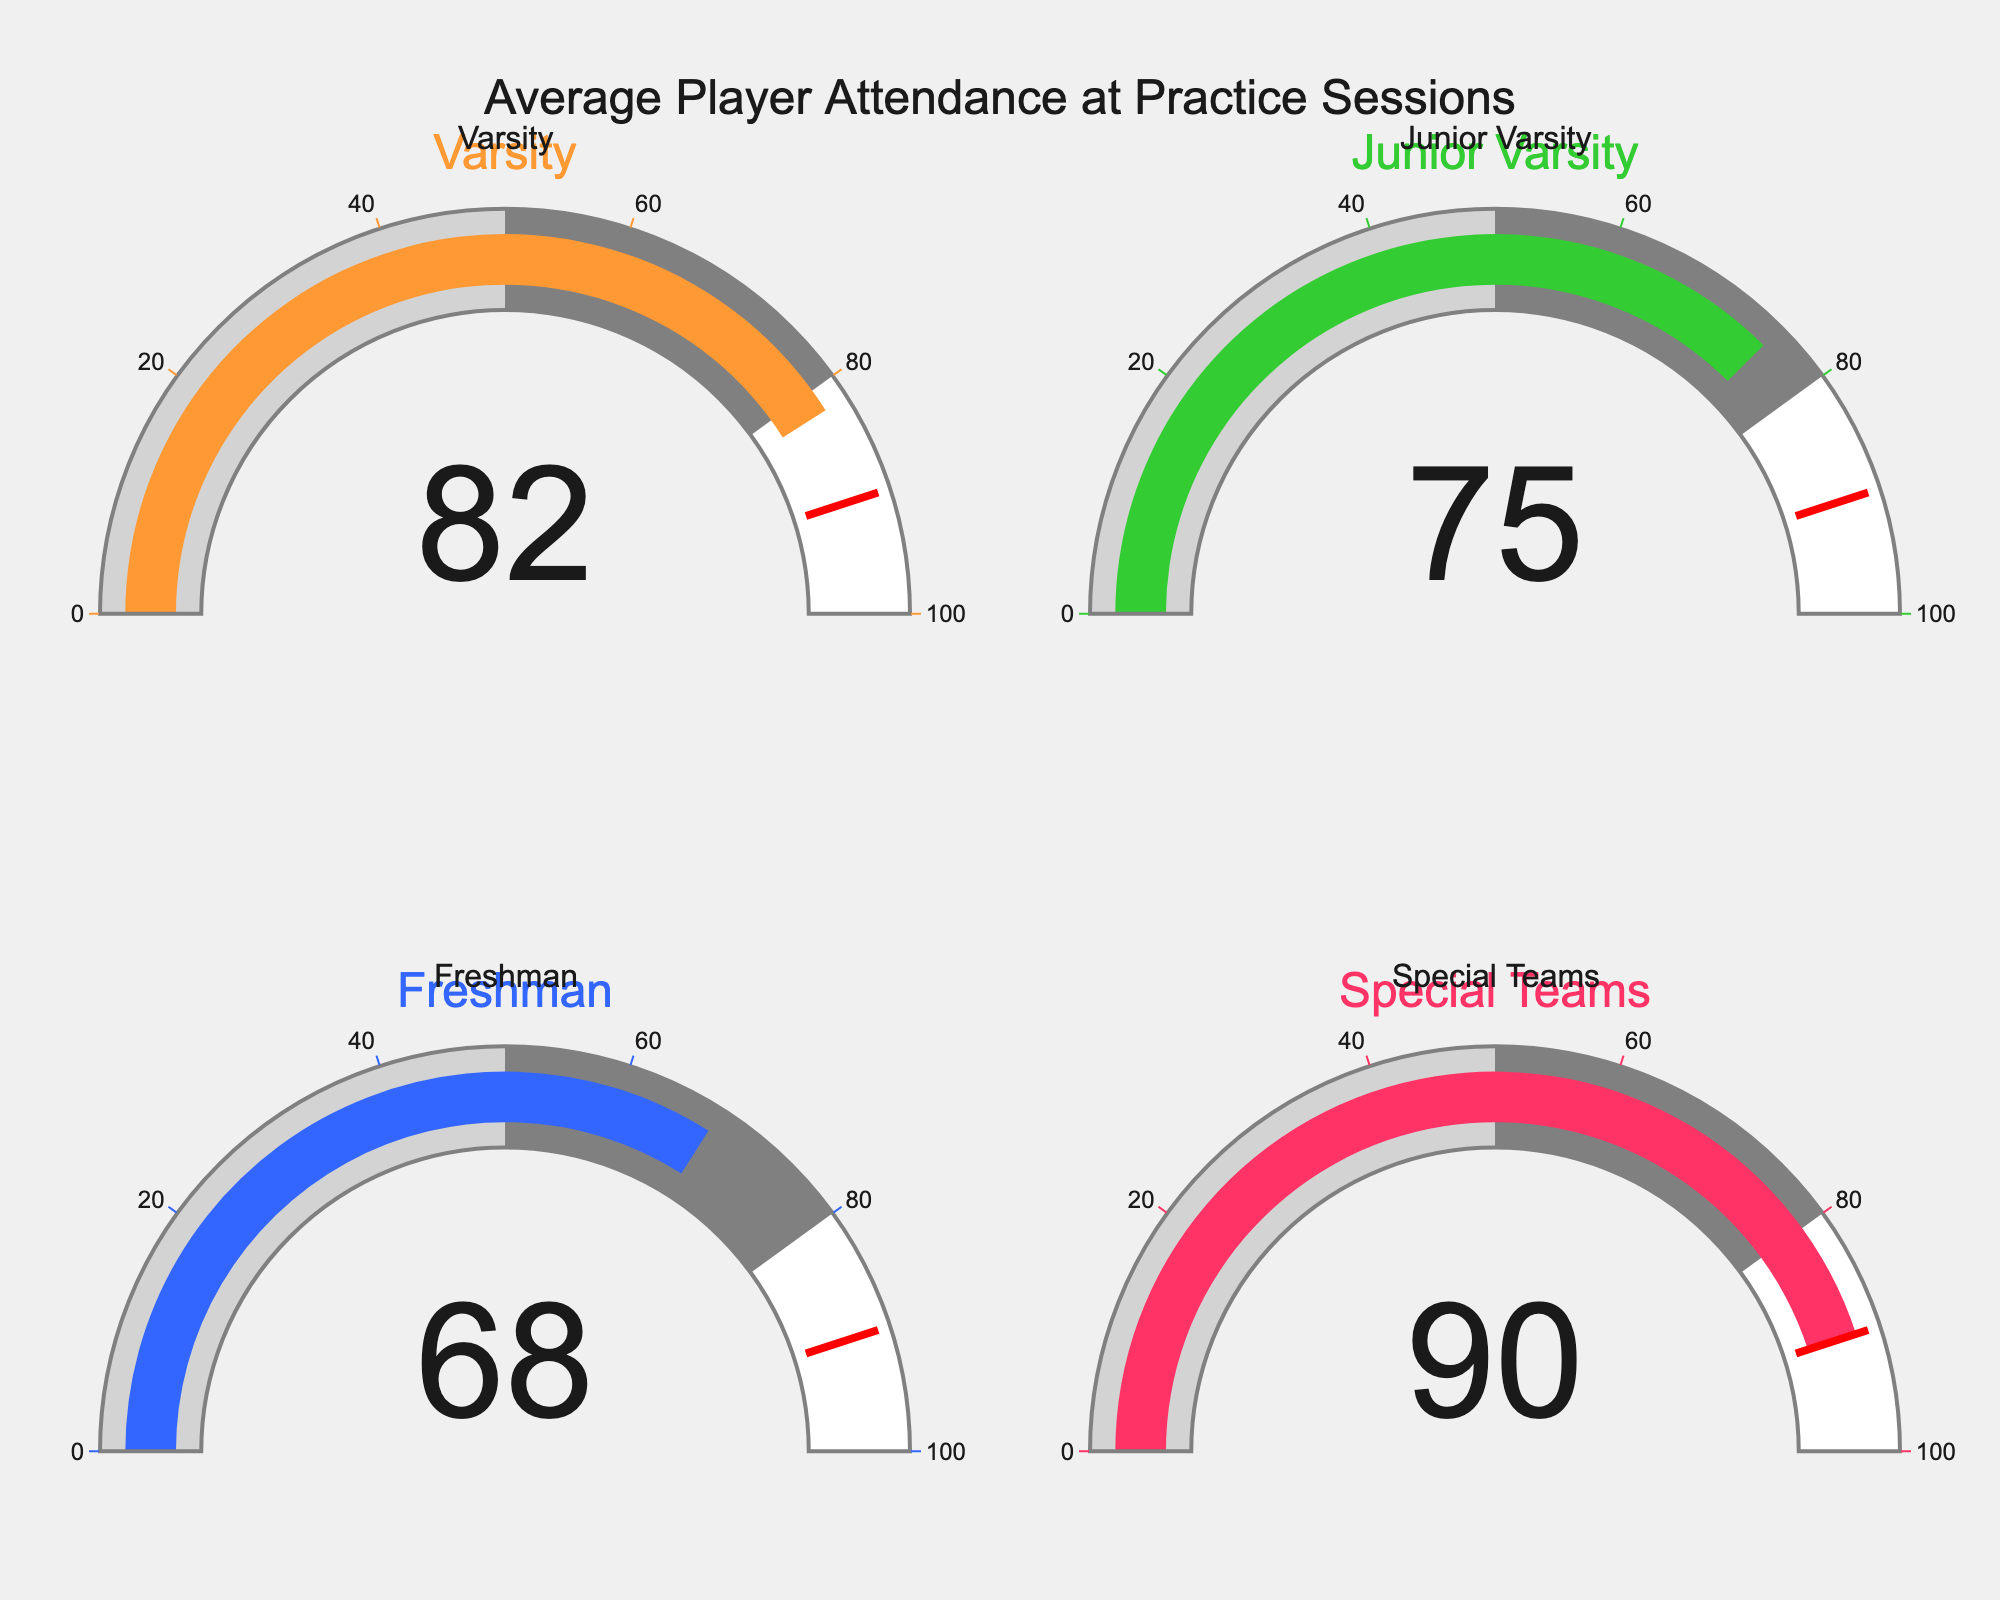What team has the highest average attendance at practice sessions? The gauge chart shows the attendance percentages for each team. The Special Teams gauge indicates a value of 90%, which is the highest among all teams displayed.
Answer: Special Teams What is the difference in attendance percentage between the Freshman team and the Varsity team? The gauge chart indicates the Freshman team's attendance at 68% and the Varsity team's attendance at 82%. The difference is calculated as 82% - 68%.
Answer: 14% Which team has an average attendance that falls below 70%? The gauge chart displays the attendance percentage for each team. The Freshman team has an attendance percentage of 68%, which is the only value below 70%.
Answer: Freshman What is the average attendance percentage across all four teams? To find the average, add the attendance percentages of all teams (82% for Varsity, 75% for Junior Varsity, 68% for Freshman, and 90% for Special Teams) and divide by four. (82 + 75 + 68 + 90) / 4 = 315 / 4 = 78.75
Answer: 78.75% Is any team's attendance percentage exceeding the threshold of 90%? The gauge chart indicates that the Special Teams have an attendance percentage of exactly 90%, with no team's attendance percentage exceeding this value.
Answer: No Which team has the second highest average attendance at practice sessions? The highest attendance is 90% (Special Teams). The next highest is 82% (Varsity).
Answer: Varsity What is the percentage difference between the team with the highest and the team with the lowest attendance? The highest attendance percentage is 90% (Special Teams), and the lowest is 68% (Freshman). The percentage difference is 90% - 68%.
Answer: 22% How many teams have an attendance percentage above 75%? The gauge chart shows that the Varsity (82%), Junior Varsity (75%), and Special Teams (90%) all have attendance percentages above 75%, except for Junior Varsity which is exactly 75%. Therefore, Varsity and Special Teams exceed 75%.
Answer: 2 What is the median attendance percentage for the four teams? To find the median, first list the attendance percentages in ascending order: 68%, 75%, 82%, and 90%. Since there are four data points, the median will be the average of the second and third values: (75 + 82) / 2.
Answer: 78.5 